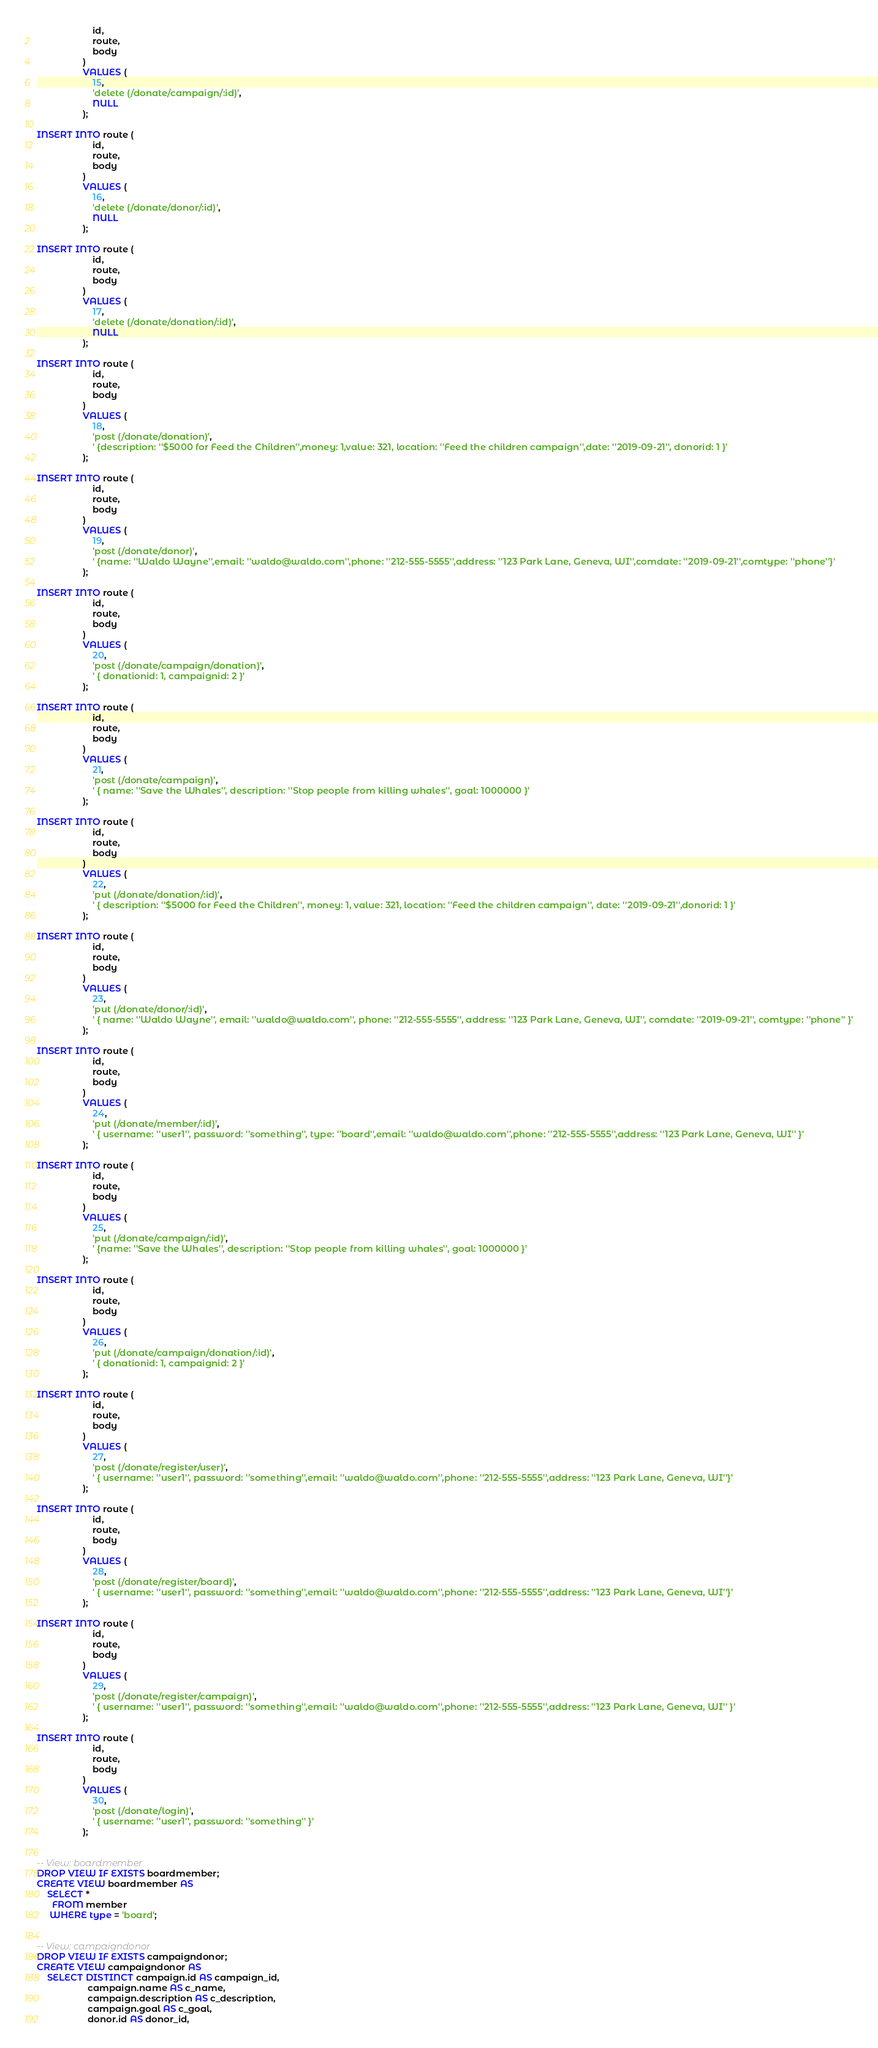Convert code to text. <code><loc_0><loc_0><loc_500><loc_500><_SQL_>                      id,
                      route,
                      body
                  )
                  VALUES (
                      15,
                      'delete (/donate/campaign/:id)',
                      NULL
                  );

INSERT INTO route (
                      id,
                      route,
                      body
                  )
                  VALUES (
                      16,
                      'delete (/donate/donor/:id)',
                      NULL
                  );

INSERT INTO route (
                      id,
                      route,
                      body
                  )
                  VALUES (
                      17,
                      'delete (/donate/donation/:id)',
                      NULL
                  );

INSERT INTO route (
                      id,
                      route,
                      body
                  )
                  VALUES (
                      18,
                      'post (/donate/donation)',
                      ' {description: ''$5000 for Feed the Children'',money: 1,value: 321, location: ''Feed the children campaign'',date: ''2019-09-21'', donorid: 1 }'
                  );

INSERT INTO route (
                      id,
                      route,
                      body
                  )
                  VALUES (
                      19,
                      'post (/donate/donor)',
                      ' {name: ''Waldo Wayne'',email: ''waldo@waldo.com'',phone: ''212-555-5555'',address: ''123 Park Lane, Geneva, WI'',comdate: ''2019-09-21'',comtype: ''phone''}'
                  );

INSERT INTO route (
                      id,
                      route,
                      body
                  )
                  VALUES (
                      20,
                      'post (/donate/campaign/donation)',
                      ' { donationid: 1, campaignid: 2 }'
                  );

INSERT INTO route (
                      id,
                      route,
                      body
                  )
                  VALUES (
                      21,
                      'post (/donate/campaign)',
                      ' { name: ''Save the Whales'', description: ''Stop people from killing whales'', goal: 1000000 }'
                  );

INSERT INTO route (
                      id,
                      route,
                      body
                  )
                  VALUES (
                      22,
                      'put (/donate/donation/:id)',
                      ' { description: ''$5000 for Feed the Children'', money: 1, value: 321, location: ''Feed the children campaign'', date: ''2019-09-21'',donorid: 1 }'
                  );

INSERT INTO route (
                      id,
                      route,
                      body
                  )
                  VALUES (
                      23,
                      'put (/donate/donor/:id)',
                      ' { name: ''Waldo Wayne'', email: ''waldo@waldo.com'', phone: ''212-555-5555'', address: ''123 Park Lane, Geneva, WI'', comdate: ''2019-09-21'', comtype: ''phone'' }'
                  );

INSERT INTO route (
                      id,
                      route,
                      body
                  )
                  VALUES (
                      24,
                      'put (/donate/member/:id)',
                      ' { username: ''user1'', password: ''something'', type: ''board'',email: ''waldo@waldo.com'',phone: ''212-555-5555'',address: ''123 Park Lane, Geneva, WI'' }'
                  );

INSERT INTO route (
                      id,
                      route,
                      body
                  )
                  VALUES (
                      25,
                      'put (/donate/campaign/:id)',
                      ' {name: ''Save the Whales'', description: ''Stop people from killing whales'', goal: 1000000 }'
                  );

INSERT INTO route (
                      id,
                      route,
                      body
                  )
                  VALUES (
                      26,
                      'put (/donate/campaign/donation/:id)',
                      ' { donationid: 1, campaignid: 2 }'
                  );

INSERT INTO route (
                      id,
                      route,
                      body
                  )
                  VALUES (
                      27,
                      'post (/donate/register/user)',
                      ' { username: ''user1'', password: ''something'',email: ''waldo@waldo.com'',phone: ''212-555-5555'',address: ''123 Park Lane, Geneva, WI''}'
                  );

INSERT INTO route (
                      id,
                      route,
                      body
                  )
                  VALUES (
                      28,
                      'post (/donate/register/board)',
                      ' { username: ''user1'', password: ''something'',email: ''waldo@waldo.com'',phone: ''212-555-5555'',address: ''123 Park Lane, Geneva, WI''}'
                  );

INSERT INTO route (
                      id,
                      route,
                      body
                  )
                  VALUES (
                      29,
                      'post (/donate/register/campaign)',
                      ' { username: ''user1'', password: ''something'',email: ''waldo@waldo.com'',phone: ''212-555-5555'',address: ''123 Park Lane, Geneva, WI'' }'
                  );

INSERT INTO route (
                      id,
                      route,
                      body
                  )
                  VALUES (
                      30,
                      'post (/donate/login)',
                      ' { username: ''user1'', password: ''something'' }'
                  );


-- View: boardmember
DROP VIEW IF EXISTS boardmember;
CREATE VIEW boardmember AS
    SELECT *
      FROM member
     WHERE type = 'board';


-- View: campaigndonor
DROP VIEW IF EXISTS campaigndonor;
CREATE VIEW campaigndonor AS
    SELECT DISTINCT campaign.id AS campaign_id,
                    campaign.name AS c_name,
                    campaign.description AS c_description,
                    campaign.goal AS c_goal,
                    donor.id AS donor_id,</code> 